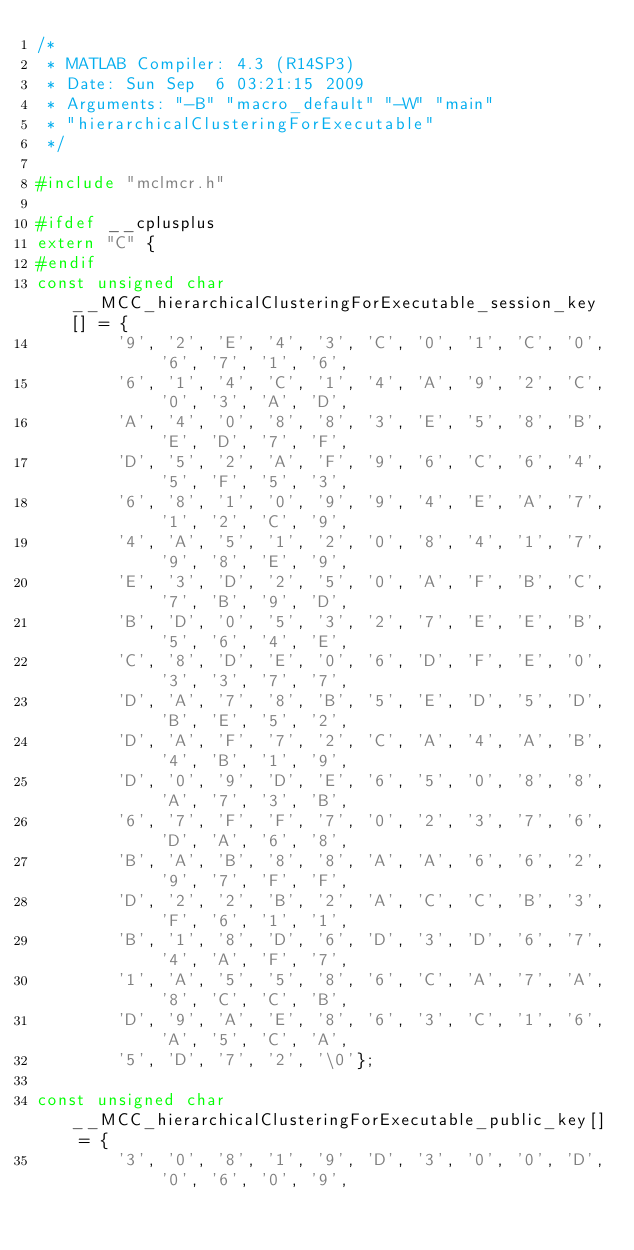Convert code to text. <code><loc_0><loc_0><loc_500><loc_500><_C_>/*
 * MATLAB Compiler: 4.3 (R14SP3)
 * Date: Sun Sep  6 03:21:15 2009
 * Arguments: "-B" "macro_default" "-W" "main"
 * "hierarchicalClusteringForExecutable" 
 */

#include "mclmcr.h"

#ifdef __cplusplus
extern "C" {
#endif
const unsigned char __MCC_hierarchicalClusteringForExecutable_session_key[] = {
        '9', '2', 'E', '4', '3', 'C', '0', '1', 'C', '0', '6', '7', '1', '6',
        '6', '1', '4', 'C', '1', '4', 'A', '9', '2', 'C', '0', '3', 'A', 'D',
        'A', '4', '0', '8', '8', '3', 'E', '5', '8', 'B', 'E', 'D', '7', 'F',
        'D', '5', '2', 'A', 'F', '9', '6', 'C', '6', '4', '5', 'F', '5', '3',
        '6', '8', '1', '0', '9', '9', '4', 'E', 'A', '7', '1', '2', 'C', '9',
        '4', 'A', '5', '1', '2', '0', '8', '4', '1', '7', '9', '8', 'E', '9',
        'E', '3', 'D', '2', '5', '0', 'A', 'F', 'B', 'C', '7', 'B', '9', 'D',
        'B', 'D', '0', '5', '3', '2', '7', 'E', 'E', 'B', '5', '6', '4', 'E',
        'C', '8', 'D', 'E', '0', '6', 'D', 'F', 'E', '0', '3', '3', '7', '7',
        'D', 'A', '7', '8', 'B', '5', 'E', 'D', '5', 'D', 'B', 'E', '5', '2',
        'D', 'A', 'F', '7', '2', 'C', 'A', '4', 'A', 'B', '4', 'B', '1', '9',
        'D', '0', '9', 'D', 'E', '6', '5', '0', '8', '8', 'A', '7', '3', 'B',
        '6', '7', 'F', 'F', '7', '0', '2', '3', '7', '6', 'D', 'A', '6', '8',
        'B', 'A', 'B', '8', '8', 'A', 'A', '6', '6', '2', '9', '7', 'F', 'F',
        'D', '2', '2', 'B', '2', 'A', 'C', 'C', 'B', '3', 'F', '6', '1', '1',
        'B', '1', '8', 'D', '6', 'D', '3', 'D', '6', '7', '4', 'A', 'F', '7',
        '1', 'A', '5', '5', '8', '6', 'C', 'A', '7', 'A', '8', 'C', 'C', 'B',
        'D', '9', 'A', 'E', '8', '6', '3', 'C', '1', '6', 'A', '5', 'C', 'A',
        '5', 'D', '7', '2', '\0'};

const unsigned char __MCC_hierarchicalClusteringForExecutable_public_key[] = {
        '3', '0', '8', '1', '9', 'D', '3', '0', '0', 'D', '0', '6', '0', '9',</code> 